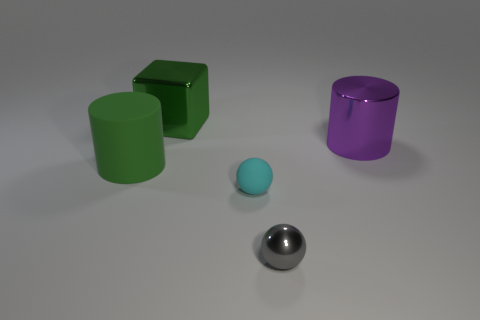There is a big metal block; are there any green metallic objects on the left side of it?
Give a very brief answer. No. Does the purple thing have the same size as the cylinder that is to the left of the tiny rubber ball?
Your answer should be compact. Yes. What is the color of the cylinder that is right of the green thing that is to the right of the matte cylinder?
Offer a terse response. Purple. Do the cyan matte ball and the green cylinder have the same size?
Your answer should be compact. No. What color is the object that is both to the left of the small shiny thing and in front of the big rubber cylinder?
Your answer should be compact. Cyan. What size is the green metallic object?
Provide a short and direct response. Large. Do the big object to the left of the large green metallic cube and the small rubber object have the same color?
Give a very brief answer. No. Is the number of tiny matte things that are in front of the gray object greater than the number of big metal blocks that are in front of the large green rubber thing?
Give a very brief answer. No. Is the number of small rubber objects greater than the number of tiny purple metallic things?
Give a very brief answer. Yes. What is the size of the shiny object that is both to the left of the large purple metallic thing and behind the small gray metal ball?
Your response must be concise. Large. 